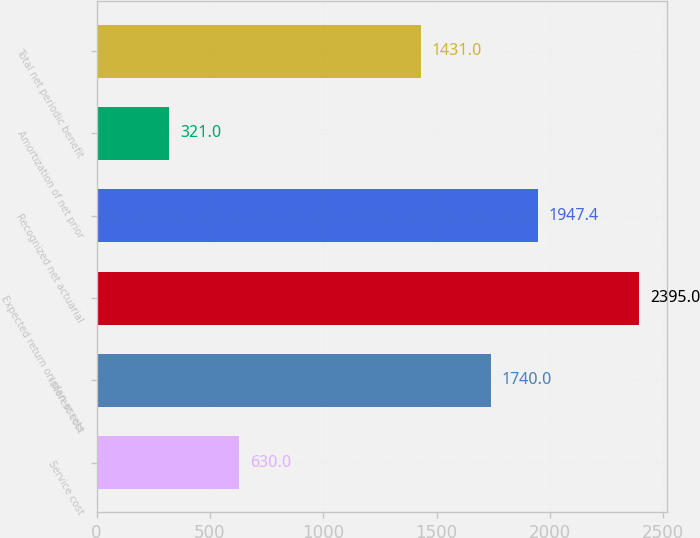Convert chart. <chart><loc_0><loc_0><loc_500><loc_500><bar_chart><fcel>Service cost<fcel>Interest cost<fcel>Expected return on plan assets<fcel>Recognized net actuarial<fcel>Amortization of net prior<fcel>Total net periodic benefit<nl><fcel>630<fcel>1740<fcel>2395<fcel>1947.4<fcel>321<fcel>1431<nl></chart> 